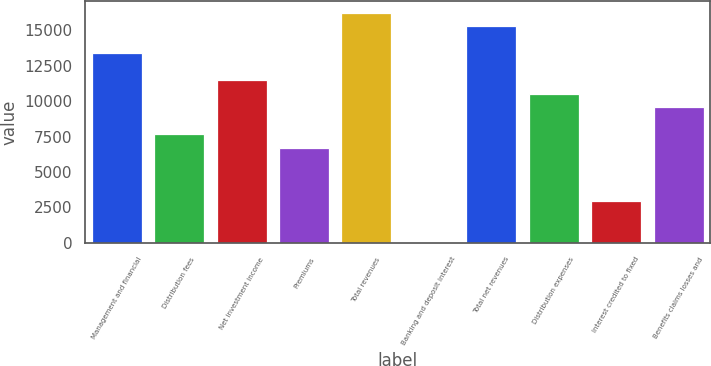Convert chart to OTSL. <chart><loc_0><loc_0><loc_500><loc_500><bar_chart><fcel>Management and financial<fcel>Distribution fees<fcel>Net investment income<fcel>Premiums<fcel>Total revenues<fcel>Banking and deposit interest<fcel>Total net revenues<fcel>Distribution expenses<fcel>Interest credited to fixed<fcel>Benefits claims losses and<nl><fcel>13386.8<fcel>7679.6<fcel>11484.4<fcel>6728.4<fcel>16240.4<fcel>70<fcel>15289.2<fcel>10533.2<fcel>2923.6<fcel>9582<nl></chart> 